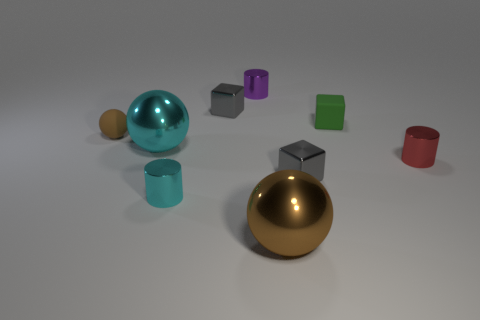Subtract all blocks. How many objects are left? 6 Add 8 big metal balls. How many big metal balls are left? 10 Add 3 big objects. How many big objects exist? 5 Subtract 0 red cubes. How many objects are left? 9 Subtract all gray metallic blocks. Subtract all purple shiny things. How many objects are left? 6 